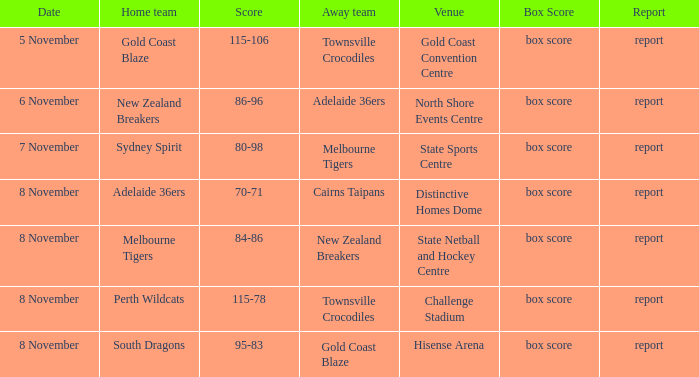Who was the home team at Gold Coast Convention Centre? Gold Coast Blaze. 